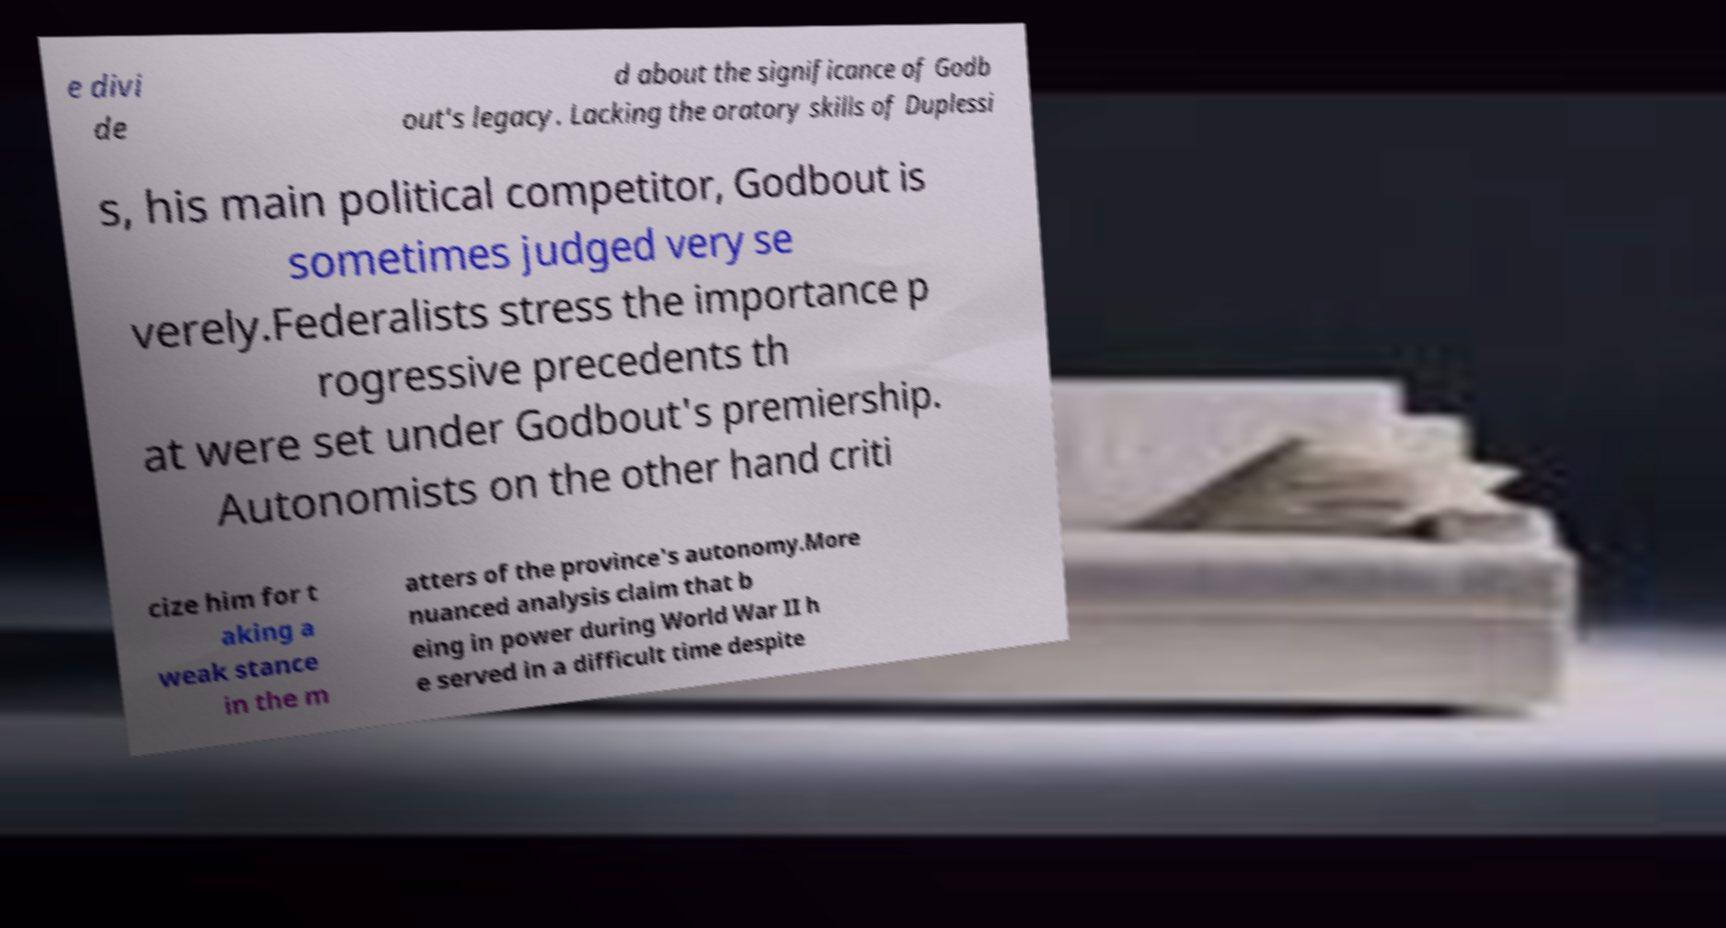Could you assist in decoding the text presented in this image and type it out clearly? e divi de d about the significance of Godb out's legacy. Lacking the oratory skills of Duplessi s, his main political competitor, Godbout is sometimes judged very se verely.Federalists stress the importance p rogressive precedents th at were set under Godbout's premiership. Autonomists on the other hand criti cize him for t aking a weak stance in the m atters of the province's autonomy.More nuanced analysis claim that b eing in power during World War II h e served in a difficult time despite 